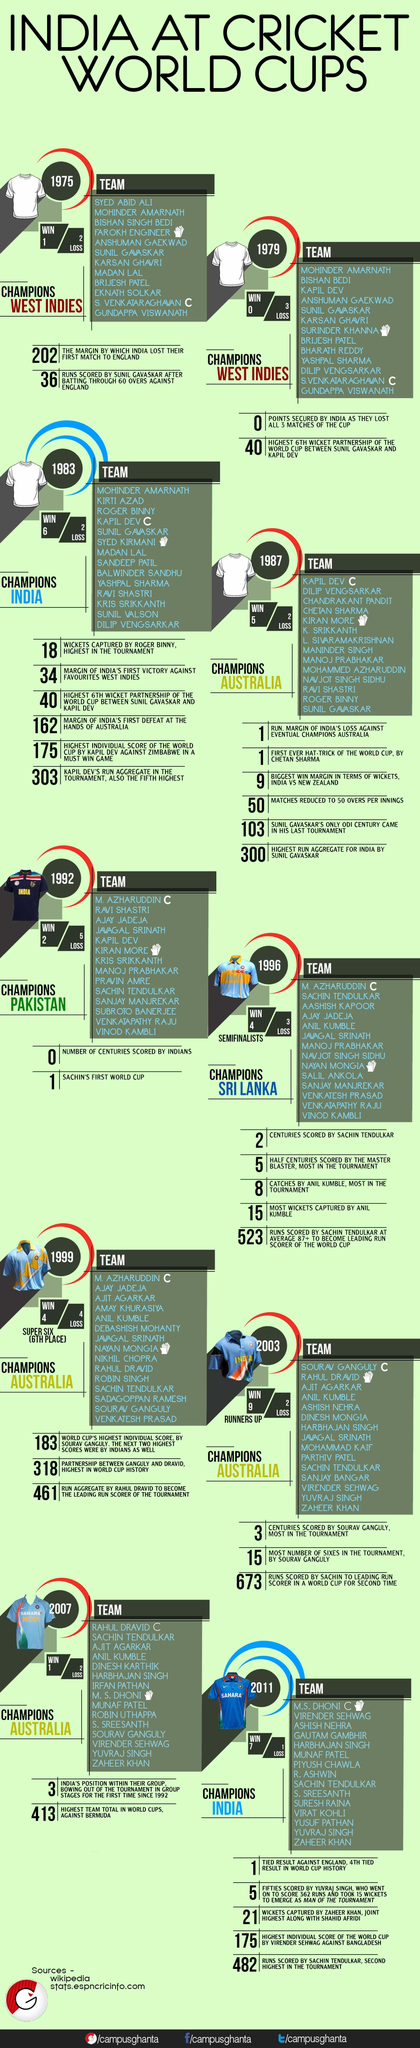Outline some significant characteristics in this image. India won the World Cup championship two times. In the year 1996, Sri Lanka won the World Cup championship. Australia has won the World Cup championship four times. India won the championship in 2011. Pakistan won the World Cup in 1992. 